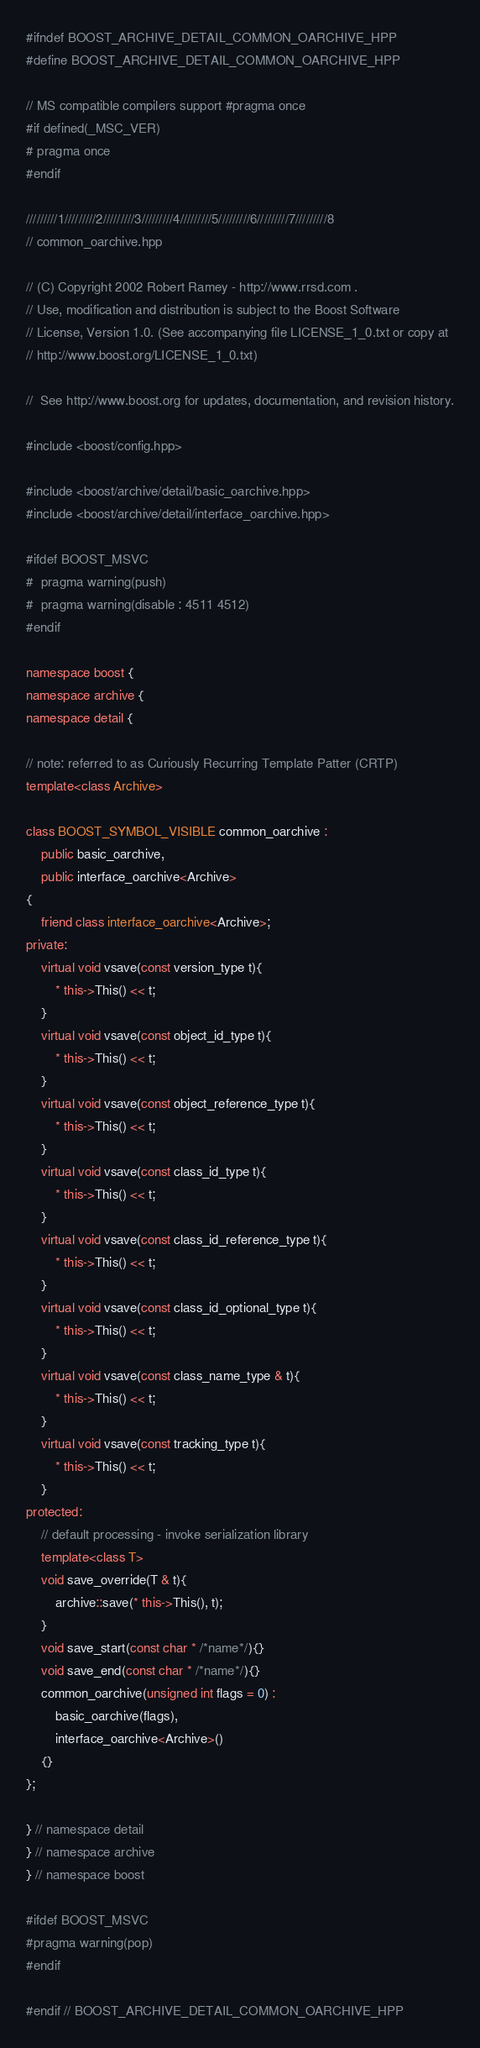<code> <loc_0><loc_0><loc_500><loc_500><_C++_>#ifndef BOOST_ARCHIVE_DETAIL_COMMON_OARCHIVE_HPP
#define BOOST_ARCHIVE_DETAIL_COMMON_OARCHIVE_HPP

// MS compatible compilers support #pragma once
#if defined(_MSC_VER)
# pragma once
#endif

/////////1/////////2/////////3/////////4/////////5/////////6/////////7/////////8
// common_oarchive.hpp

// (C) Copyright 2002 Robert Ramey - http://www.rrsd.com .
// Use, modification and distribution is subject to the Boost Software
// License, Version 1.0. (See accompanying file LICENSE_1_0.txt or copy at
// http://www.boost.org/LICENSE_1_0.txt)

//  See http://www.boost.org for updates, documentation, and revision history.

#include <boost/config.hpp>

#include <boost/archive/detail/basic_oarchive.hpp>
#include <boost/archive/detail/interface_oarchive.hpp>

#ifdef BOOST_MSVC
#  pragma warning(push)
#  pragma warning(disable : 4511 4512)
#endif

namespace boost {
namespace archive {
namespace detail {

// note: referred to as Curiously Recurring Template Patter (CRTP)
template<class Archive>

class BOOST_SYMBOL_VISIBLE common_oarchive :
    public basic_oarchive,
    public interface_oarchive<Archive>
{
    friend class interface_oarchive<Archive>;
private:
    virtual void vsave(const version_type t){
        * this->This() << t;
    }
    virtual void vsave(const object_id_type t){
        * this->This() << t;
    }
    virtual void vsave(const object_reference_type t){
        * this->This() << t;
    }
    virtual void vsave(const class_id_type t){
        * this->This() << t;
    }
    virtual void vsave(const class_id_reference_type t){
        * this->This() << t;
    }
    virtual void vsave(const class_id_optional_type t){
        * this->This() << t;
    }
    virtual void vsave(const class_name_type & t){
        * this->This() << t;
    }
    virtual void vsave(const tracking_type t){
        * this->This() << t;
    }
protected:
    // default processing - invoke serialization library
    template<class T>
    void save_override(T & t){
        archive::save(* this->This(), t);
    }
    void save_start(const char * /*name*/){}
    void save_end(const char * /*name*/){}
    common_oarchive(unsigned int flags = 0) :
        basic_oarchive(flags),
        interface_oarchive<Archive>()
    {}
};

} // namespace detail
} // namespace archive
} // namespace boost

#ifdef BOOST_MSVC
#pragma warning(pop)
#endif

#endif // BOOST_ARCHIVE_DETAIL_COMMON_OARCHIVE_HPP
</code> 